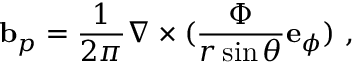Convert formula to latex. <formula><loc_0><loc_0><loc_500><loc_500>{ b } _ { p } = \frac { 1 } { 2 \pi } \nabla \times ( \frac { \Phi } { r \sin \theta } { e } _ { \phi } ) \ ,</formula> 